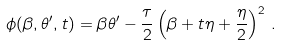<formula> <loc_0><loc_0><loc_500><loc_500>\phi ( \beta , \theta ^ { \prime } , t ) = \beta \theta ^ { \prime } - \frac { \tau } { 2 } \left ( \beta + t \eta + \frac { \eta } { 2 } \right ) ^ { 2 } \, .</formula> 